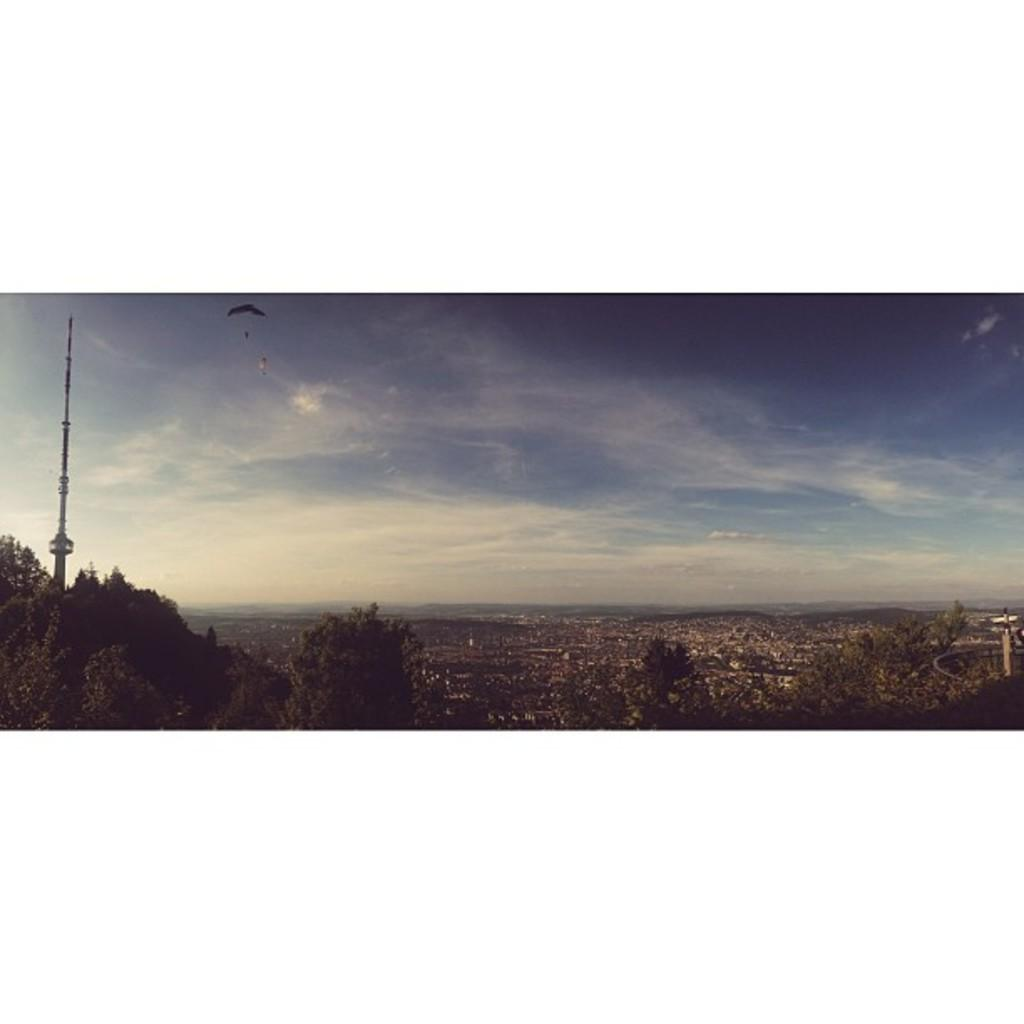What type of vegetation is visible in the image? There are many trees in the image. What structure can be seen in the image besides the trees? There is a tower in the image. What activity are the people engaged in the image? There are people flying on parachutes in the image. What type of man-made structures are present in the image? There are some buildings in the image. How many toes are visible on the people flying on parachutes in the image? The image does not show the toes of the people flying on parachutes, so it is not possible to determine the number of toes visible. Who is the representative of the trees in the image? The concept of a representative does not apply to trees in the image, as trees are inanimate objects and not capable of having representatives. 